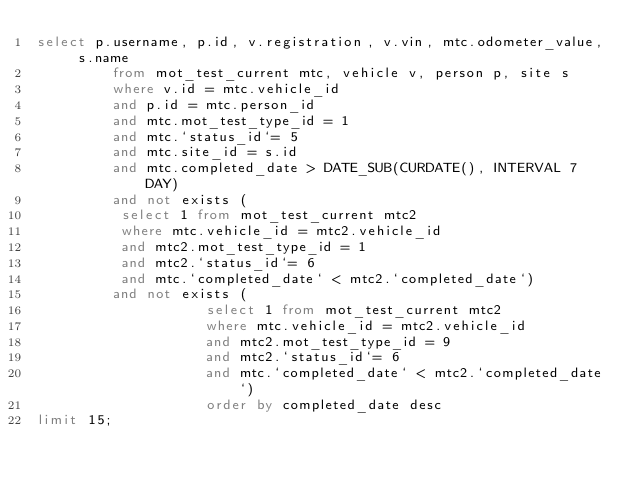Convert code to text. <code><loc_0><loc_0><loc_500><loc_500><_SQL_>select p.username, p.id, v.registration, v.vin, mtc.odometer_value, s.name
         from mot_test_current mtc, vehicle v, person p, site s
         where v.id = mtc.vehicle_id
         and p.id = mtc.person_id
         and mtc.mot_test_type_id = 1
         and mtc.`status_id`= 5
         and mtc.site_id = s.id
         and mtc.completed_date > DATE_SUB(CURDATE(), INTERVAL 7 DAY)
         and not exists (
         	select 1 from mot_test_current mtc2
         	where mtc.vehicle_id = mtc2.vehicle_id
         	and mtc2.mot_test_type_id = 1
         	and mtc2.`status_id`= 6
         	and mtc.`completed_date` < mtc2.`completed_date`)
         and not exists (
                  	select 1 from mot_test_current mtc2
                  	where mtc.vehicle_id = mtc2.vehicle_id
                  	and mtc2.mot_test_type_id = 9
                  	and mtc2.`status_id`= 6
                  	and mtc.`completed_date` < mtc2.`completed_date`)
                  	order by completed_date desc
limit 15;
</code> 